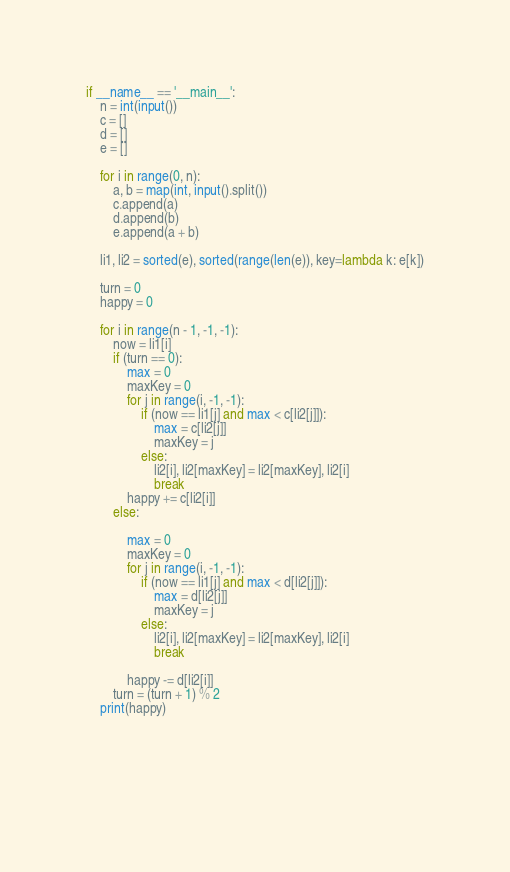<code> <loc_0><loc_0><loc_500><loc_500><_Python_>if __name__ == '__main__':
    n = int(input())
    c = []
    d = []
    e = []
    
    for i in range(0, n):
        a, b = map(int, input().split())
        c.append(a)
        d.append(b)
        e.append(a + b)
    
    li1, li2 = sorted(e), sorted(range(len(e)), key=lambda k: e[k])
    
    turn = 0
    happy = 0

    for i in range(n - 1, -1, -1):
        now = li1[i]
        if (turn == 0):
            max = 0
            maxKey = 0
            for j in range(i, -1, -1):
                if (now == li1[j] and max < c[li2[j]]):
                    max = c[li2[j]]
                    maxKey = j
                else:
                    li2[i], li2[maxKey] = li2[maxKey], li2[i]
                    break
            happy += c[li2[i]]
        else:

            max = 0
            maxKey = 0
            for j in range(i, -1, -1):
                if (now == li1[j] and max < d[li2[j]]):
                    max = d[li2[j]]
                    maxKey = j
                else:
                    li2[i], li2[maxKey] = li2[maxKey], li2[i]
                    break

            happy -= d[li2[i]]
        turn = (turn + 1) % 2
    print(happy)
    


    
    
</code> 